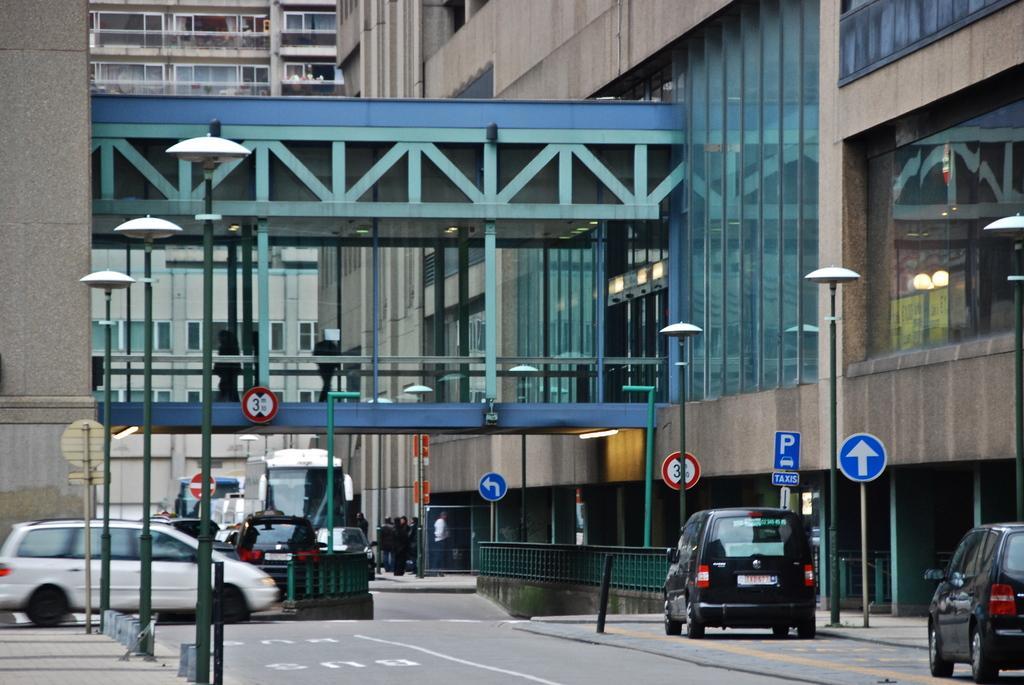Could you give a brief overview of what you see in this image? In this image I can see the road. On the road I can see many vehicles. To the side of the road I can see many boards to the poles. In the background I can see the bridge attached to the buildings. I can see these buildings are with glasses. 